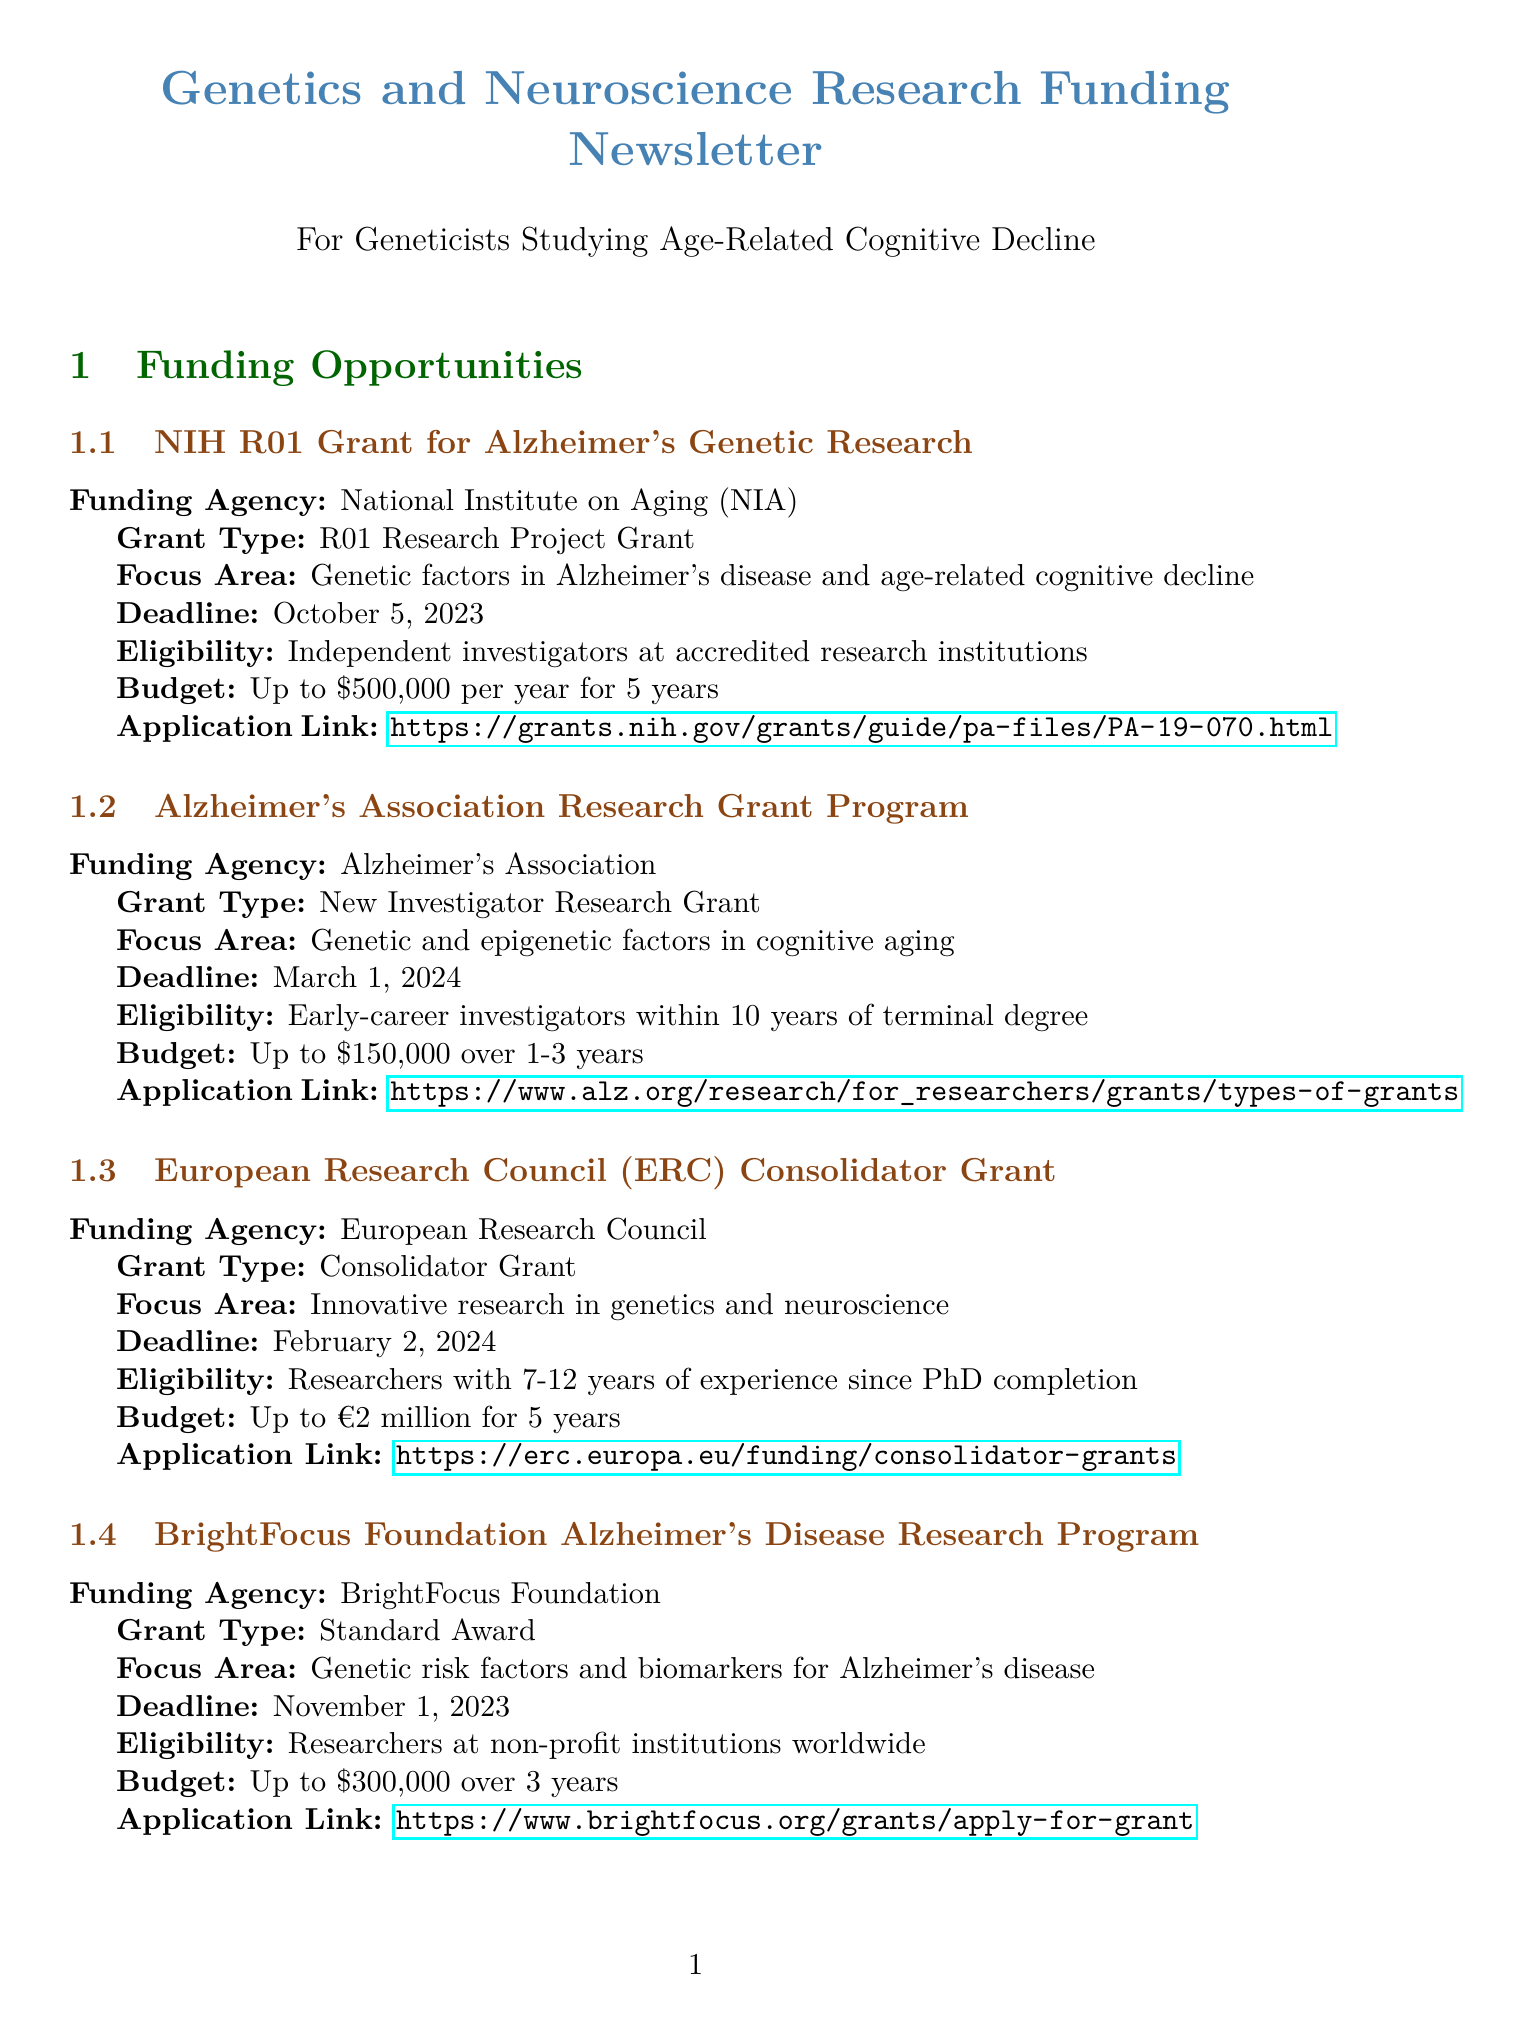What is the funding agency for the NIH R01 Grant? The funding agency for the NIH R01 Grant is specified in the document as the National Institute on Aging (NIA).
Answer: National Institute on Aging (NIA) What is the application deadline for the Alzheimer's Association Research Grant Program? The document lists the application deadline for the Alzheimer's Association Research Grant Program as March 1, 2024.
Answer: March 1, 2024 What is the maximum budget available for the European Research Council Consolidator Grant? The document states that the maximum budget for the European Research Council Consolidator Grant is up to €2 million for 5 years.
Answer: Up to €2 million for 5 years Who is eligible for the Glenn Foundation for Medical Research and AFAR Grants? The eligibility criteria mentioned in the document indicates that postdoctoral fellows within 5 years of PhD or MD are eligible for the Glenn Foundation for Medical Research and AFAR Grants.
Answer: Postdoctoral fellows within 5 years of PhD or MD What type of grant is offered by the BrightFocus Foundation? The document specifies that the BrightFocus Foundation offers a Standard Award for their Alzheimer's Disease Research Program.
Answer: Standard Award Which organization supports interdisciplinary research in genetics and neuroscience? The document identifies the Human Frontier Science Program as the organization that supports interdisciplinary research in genetics and neuroscience.
Answer: Human Frontier Science Program How many researchers are required for the Human Frontier Science Program Research Grant? The document states that the eligibility for this grant requires international teams of 2-4 researchers from different countries.
Answer: 2-4 researchers What is one of the relevant journals for publication mentioned in the document? The document lists various journals for publication, including Nature Genetics.
Answer: Nature Genetics 